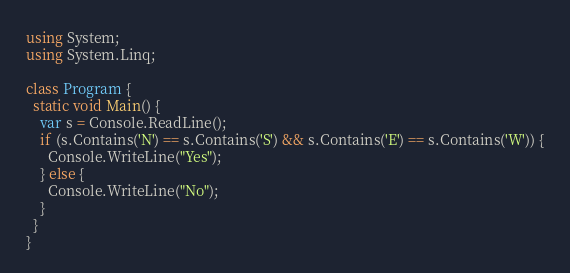Convert code to text. <code><loc_0><loc_0><loc_500><loc_500><_C#_>using System;
using System.Linq;

class Program {
  static void Main() {
    var s = Console.ReadLine();
    if (s.Contains('N') == s.Contains('S') && s.Contains('E') == s.Contains('W')) {
      Console.WriteLine("Yes");
    } else {
      Console.WriteLine("No");
    }
  }
}</code> 